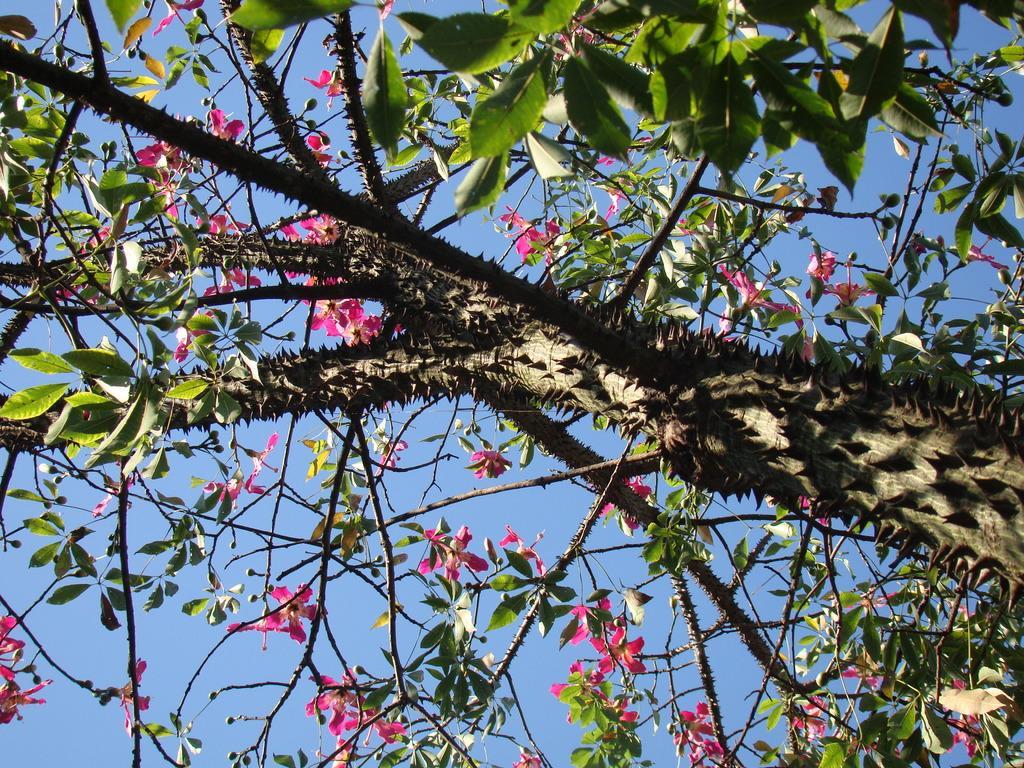Describe this image in one or two sentences. In this picture we can see a tree with flowers and leaves. Behind the tree there is a sky. 